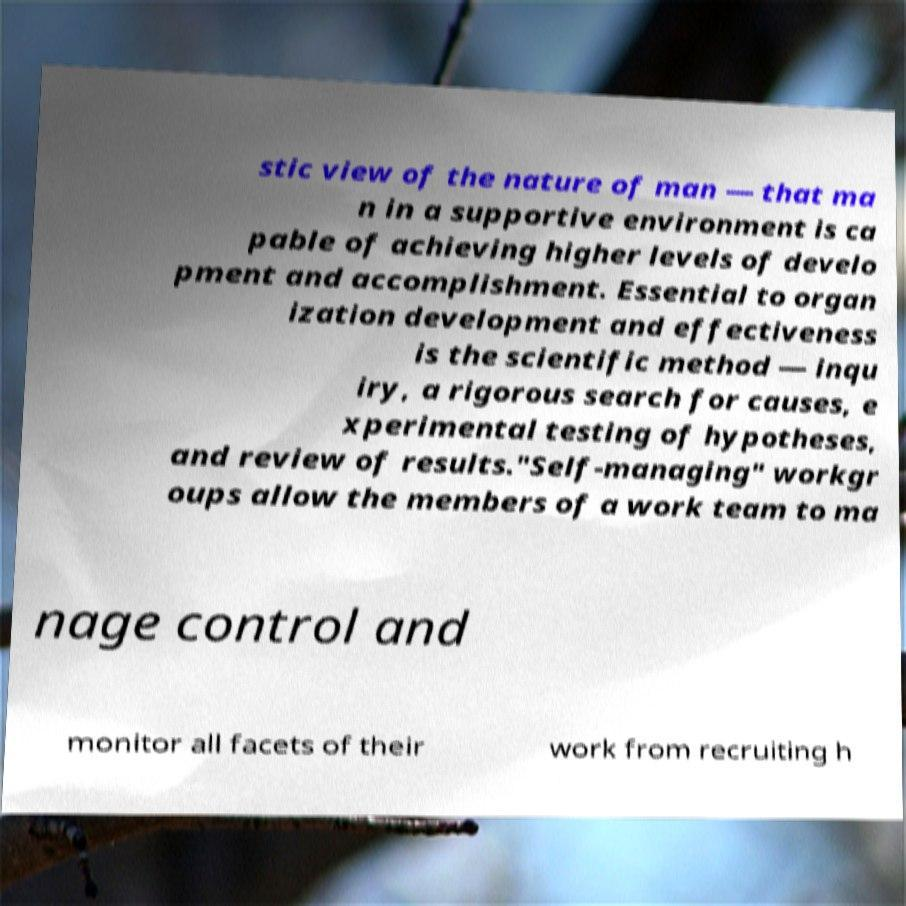Can you read and provide the text displayed in the image?This photo seems to have some interesting text. Can you extract and type it out for me? stic view of the nature of man — that ma n in a supportive environment is ca pable of achieving higher levels of develo pment and accomplishment. Essential to organ ization development and effectiveness is the scientific method — inqu iry, a rigorous search for causes, e xperimental testing of hypotheses, and review of results."Self-managing" workgr oups allow the members of a work team to ma nage control and monitor all facets of their work from recruiting h 